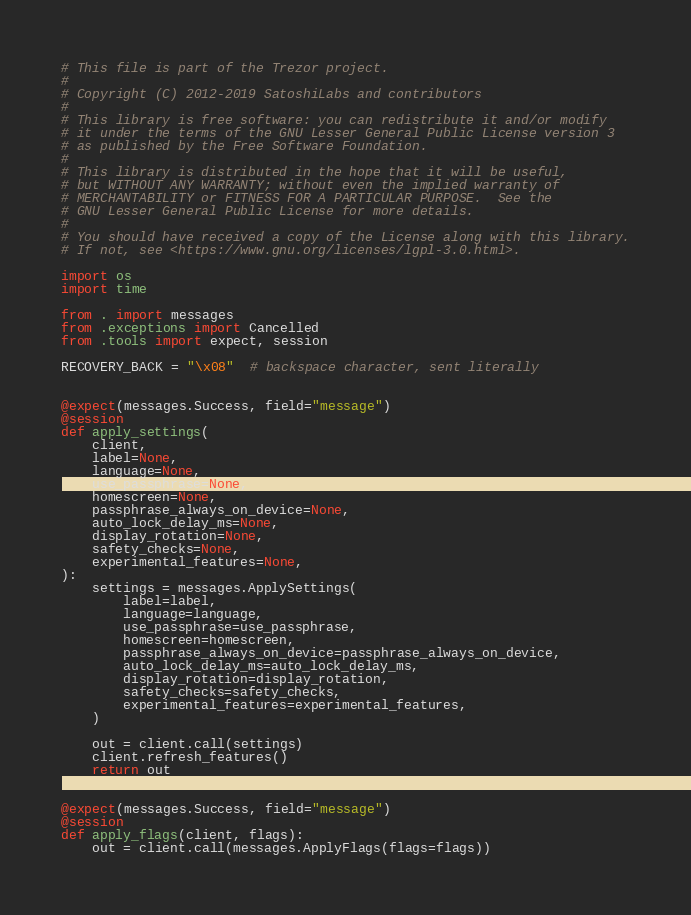Convert code to text. <code><loc_0><loc_0><loc_500><loc_500><_Python_># This file is part of the Trezor project.
#
# Copyright (C) 2012-2019 SatoshiLabs and contributors
#
# This library is free software: you can redistribute it and/or modify
# it under the terms of the GNU Lesser General Public License version 3
# as published by the Free Software Foundation.
#
# This library is distributed in the hope that it will be useful,
# but WITHOUT ANY WARRANTY; without even the implied warranty of
# MERCHANTABILITY or FITNESS FOR A PARTICULAR PURPOSE.  See the
# GNU Lesser General Public License for more details.
#
# You should have received a copy of the License along with this library.
# If not, see <https://www.gnu.org/licenses/lgpl-3.0.html>.

import os
import time

from . import messages
from .exceptions import Cancelled
from .tools import expect, session

RECOVERY_BACK = "\x08"  # backspace character, sent literally


@expect(messages.Success, field="message")
@session
def apply_settings(
    client,
    label=None,
    language=None,
    use_passphrase=None,
    homescreen=None,
    passphrase_always_on_device=None,
    auto_lock_delay_ms=None,
    display_rotation=None,
    safety_checks=None,
    experimental_features=None,
):
    settings = messages.ApplySettings(
        label=label,
        language=language,
        use_passphrase=use_passphrase,
        homescreen=homescreen,
        passphrase_always_on_device=passphrase_always_on_device,
        auto_lock_delay_ms=auto_lock_delay_ms,
        display_rotation=display_rotation,
        safety_checks=safety_checks,
        experimental_features=experimental_features,
    )

    out = client.call(settings)
    client.refresh_features()
    return out


@expect(messages.Success, field="message")
@session
def apply_flags(client, flags):
    out = client.call(messages.ApplyFlags(flags=flags))</code> 